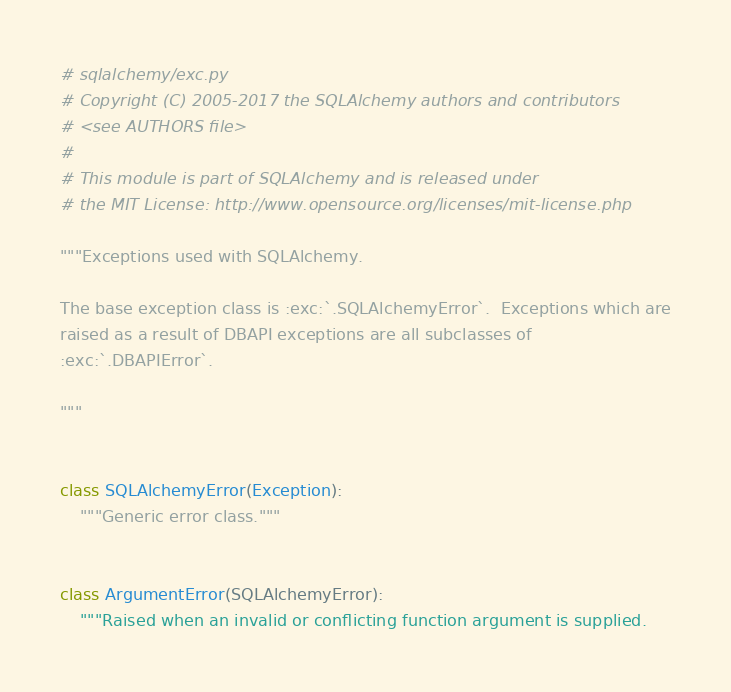<code> <loc_0><loc_0><loc_500><loc_500><_Python_># sqlalchemy/exc.py
# Copyright (C) 2005-2017 the SQLAlchemy authors and contributors
# <see AUTHORS file>
#
# This module is part of SQLAlchemy and is released under
# the MIT License: http://www.opensource.org/licenses/mit-license.php

"""Exceptions used with SQLAlchemy.

The base exception class is :exc:`.SQLAlchemyError`.  Exceptions which are
raised as a result of DBAPI exceptions are all subclasses of
:exc:`.DBAPIError`.

"""


class SQLAlchemyError(Exception):
    """Generic error class."""


class ArgumentError(SQLAlchemyError):
    """Raised when an invalid or conflicting function argument is supplied.
</code> 